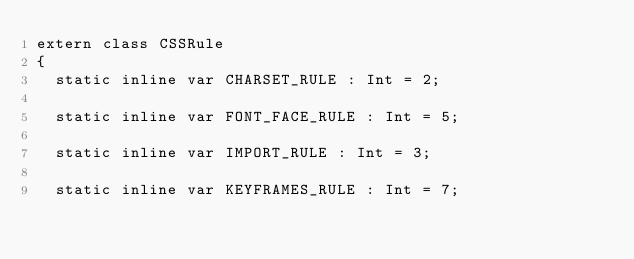Convert code to text. <code><loc_0><loc_0><loc_500><loc_500><_Haxe_>extern class CSSRule
{
	static inline var CHARSET_RULE : Int = 2;

	static inline var FONT_FACE_RULE : Int = 5;

	static inline var IMPORT_RULE : Int = 3;

	static inline var KEYFRAMES_RULE : Int = 7;
</code> 